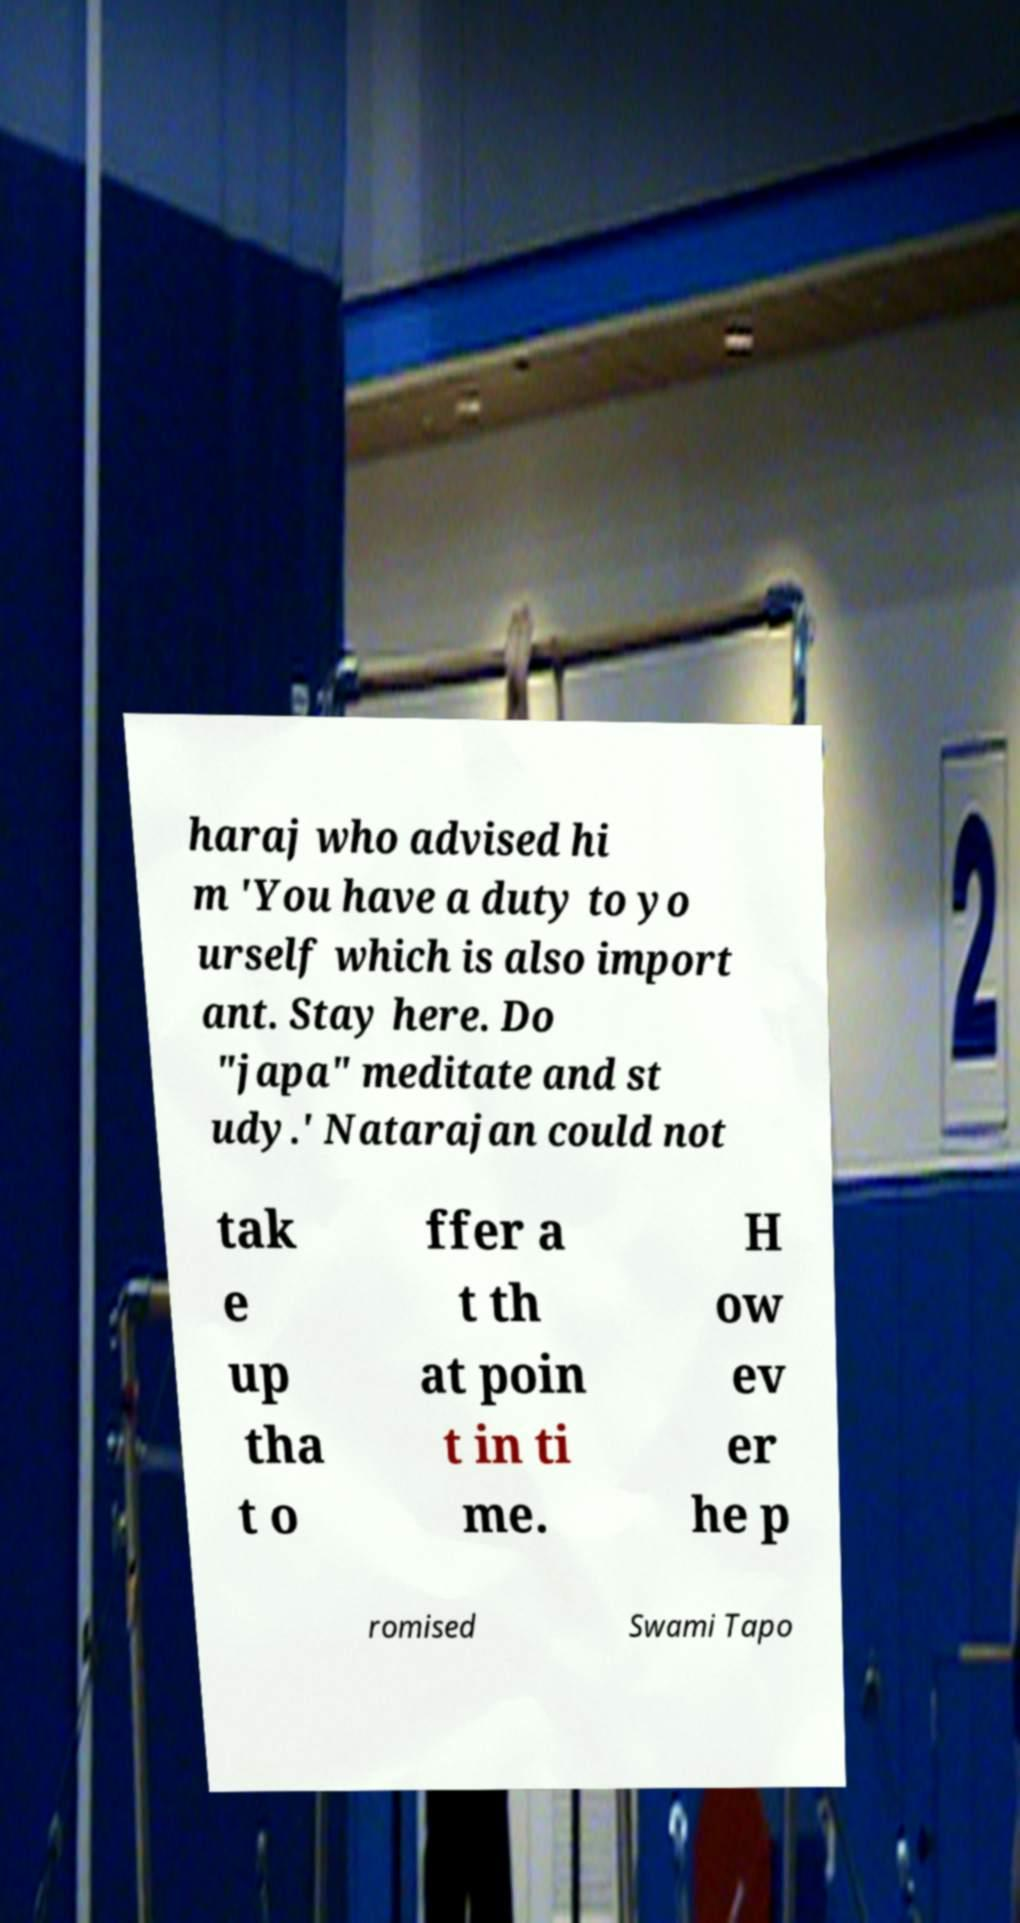Could you extract and type out the text from this image? haraj who advised hi m 'You have a duty to yo urself which is also import ant. Stay here. Do "japa" meditate and st udy.' Natarajan could not tak e up tha t o ffer a t th at poin t in ti me. H ow ev er he p romised Swami Tapo 